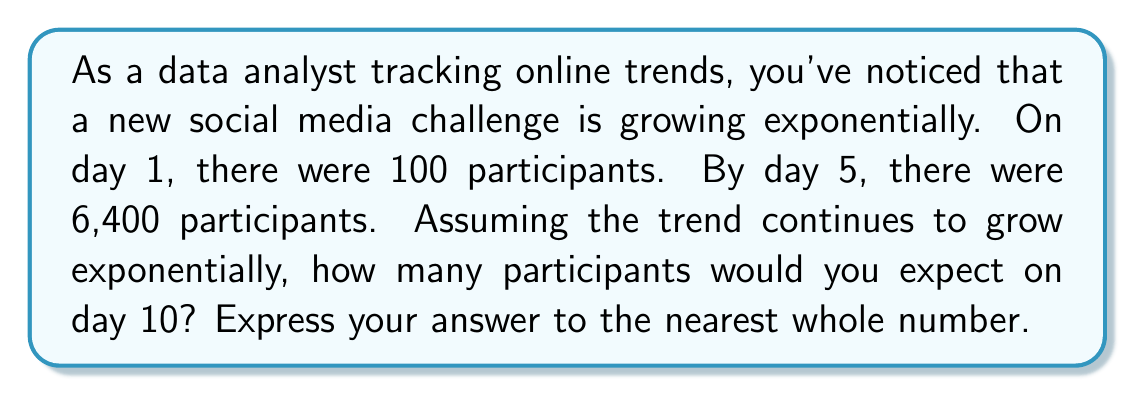Could you help me with this problem? To solve this problem, we'll use the exponential growth function:

$$A = P(1 + r)^t$$

Where:
$A$ = Final amount
$P$ = Initial amount
$r$ = Growth rate (as a decimal)
$t$ = Time period

We know:
$P = 100$ (initial participants on day 1)
$A = 6400$ (participants on day 5)
$t = 4$ (number of days between day 1 and day 5)

Let's find the growth rate:

1) Substitute the known values into the equation:
   $$6400 = 100(1 + r)^4$$

2) Divide both sides by 100:
   $$64 = (1 + r)^4$$

3) Take the fourth root of both sides:
   $$\sqrt[4]{64} = 1 + r$$
   $$2 = 1 + r$$

4) Solve for r:
   $$r = 2 - 1 = 1$$

The daily growth rate is 100% or 1.

Now, let's use this rate to find the number of participants on day 10:

5) Use the exponential growth formula:
   $$A = 100(1 + 1)^9$$
   (We use 9 as the exponent because we're calculating 9 days of growth after day 1)

6) Simplify:
   $$A = 100(2)^9 = 100 * 512 = 51,200$$

Therefore, we expect 51,200 participants on day 10.
Answer: 51,200 participants 